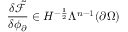<formula> <loc_0><loc_0><loc_500><loc_500>\frac { \delta \tilde { \mathcal { F } } } { \delta \phi _ { \partial } } \in H ^ { - \frac { 1 } { 2 } } \Lambda ^ { n - 1 } ( \partial \Omega )</formula> 